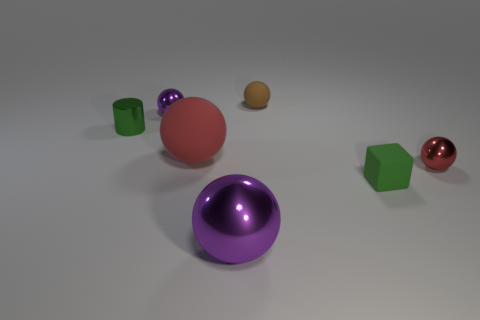What can you infer about the lighting source in this image? The lighting in the image appears to be coming from above, as indicated by the shadows directly underneath the objects. It seems to be a soft and diffused light source, given the soft edges of the shadows and the even illumination of the scene. 